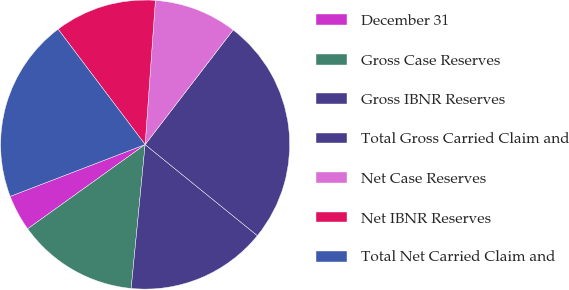<chart> <loc_0><loc_0><loc_500><loc_500><pie_chart><fcel>December 31<fcel>Gross Case Reserves<fcel>Gross IBNR Reserves<fcel>Total Gross Carried Claim and<fcel>Net Case Reserves<fcel>Net IBNR Reserves<fcel>Total Net Carried Claim and<nl><fcel>4.07%<fcel>13.56%<fcel>15.69%<fcel>25.43%<fcel>9.29%<fcel>11.42%<fcel>20.55%<nl></chart> 